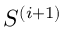<formula> <loc_0><loc_0><loc_500><loc_500>S ^ { ( i + 1 ) }</formula> 